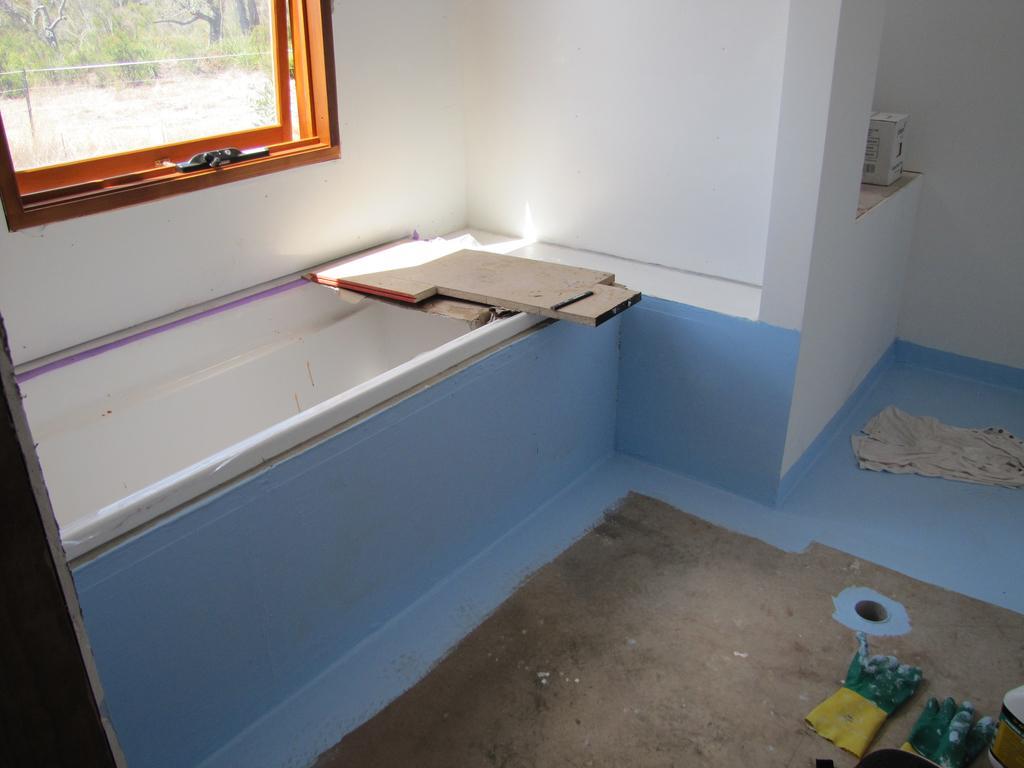How would you summarize this image in a sentence or two? In this image, we can see a bathtub, boards, carton box, wall, cloth, gloves, container and some object and floor. Top of the image, we can see a glass window. Through the glass we can see the outside view. Here we can see trees. 